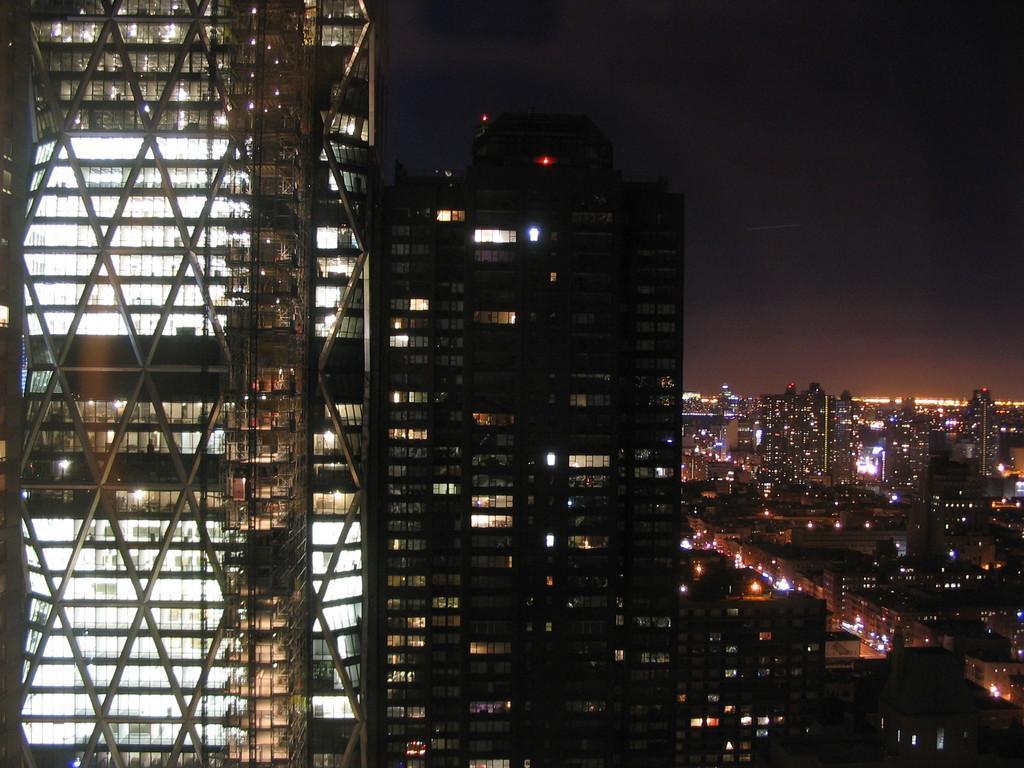Please provide a concise description of this image. In this picture we can see a group of buildings,lights and we can see sky in the background. 